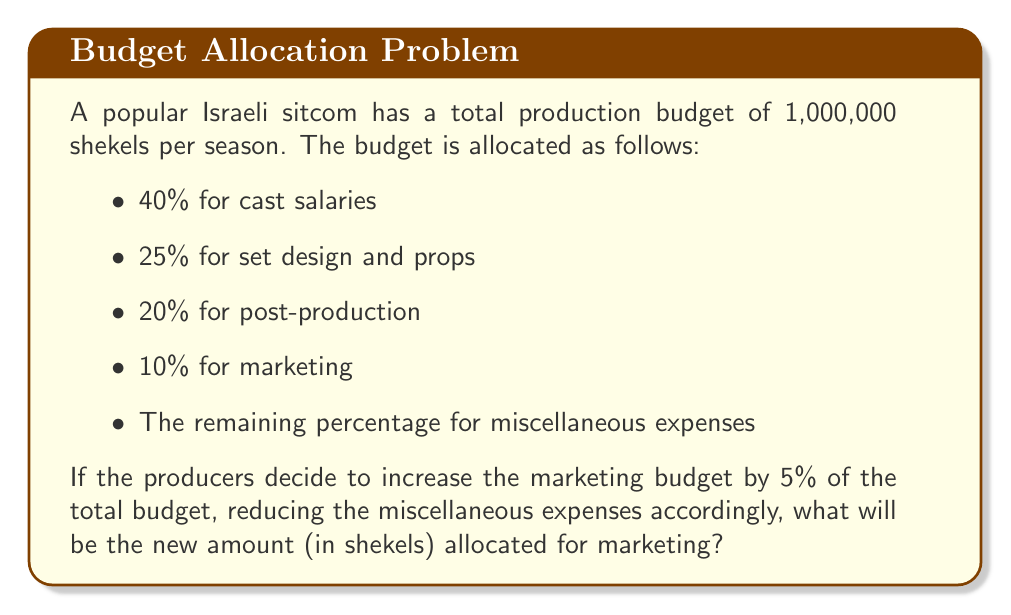Teach me how to tackle this problem. Let's approach this step-by-step:

1) First, let's calculate the initial marketing budget:
   $0.10 \times 1,000,000 = 100,000$ shekels

2) Now, let's calculate the new percentage for marketing:
   $10\% + 5\% = 15\%$

3) To find the new amount for marketing, we calculate:
   $0.15 \times 1,000,000 = 150,000$ shekels

We can verify this by checking the total allocation:
$$\begin{align*}
\text{Cast salaries:} & \quad 40\% \\
\text{Set design and props:} & \quad 25\% \\
\text{Post-production:} & \quad 20\% \\
\text{Marketing (new):} & \quad 15\% \\
\text{Miscellaneous (reduced):} & \quad 0\%
\end{align*}$$

The total is indeed 100%, confirming our calculation.
Answer: 150,000 shekels 